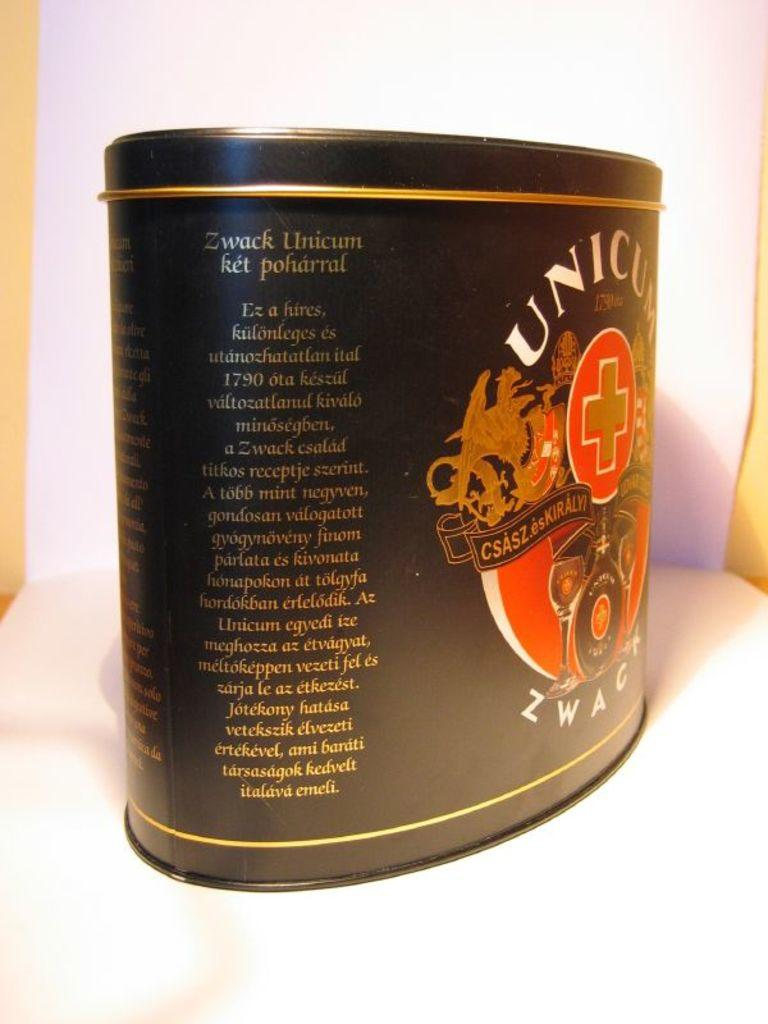Provide a one-sentence caption for the provided image. A container of Zwack Unicum turned to the description label. 